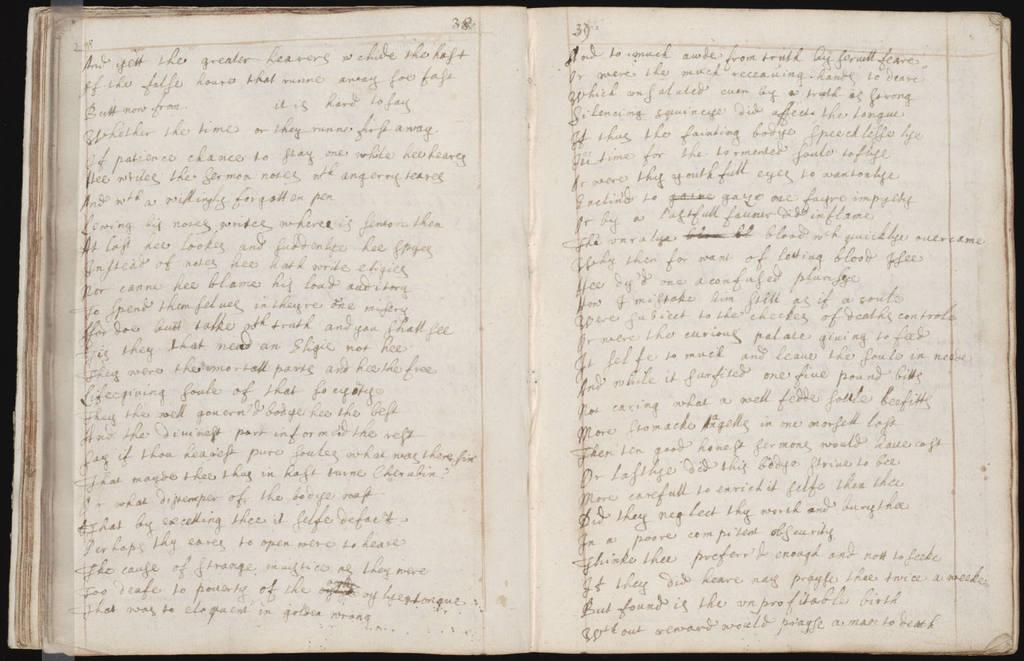<image>
Describe the image concisely. A book is open to a page that ends with the word "death". 